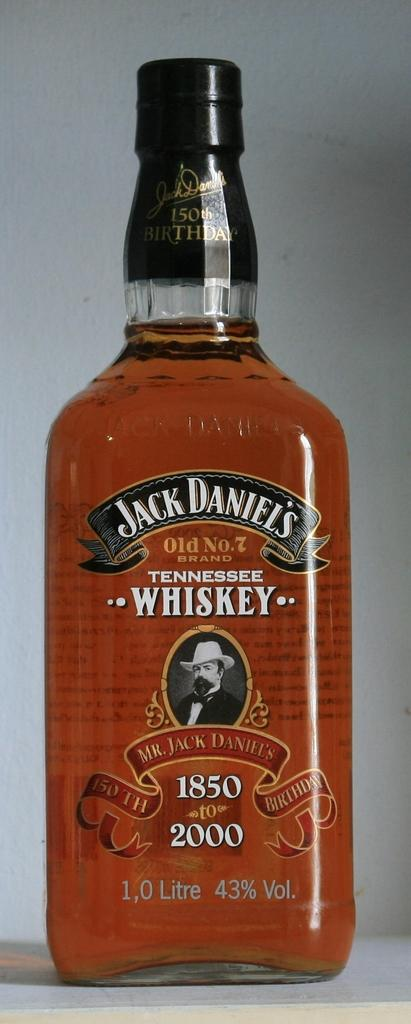<image>
Give a short and clear explanation of the subsequent image. A litre of Jack Daniels whiskey is displayed on a surface 